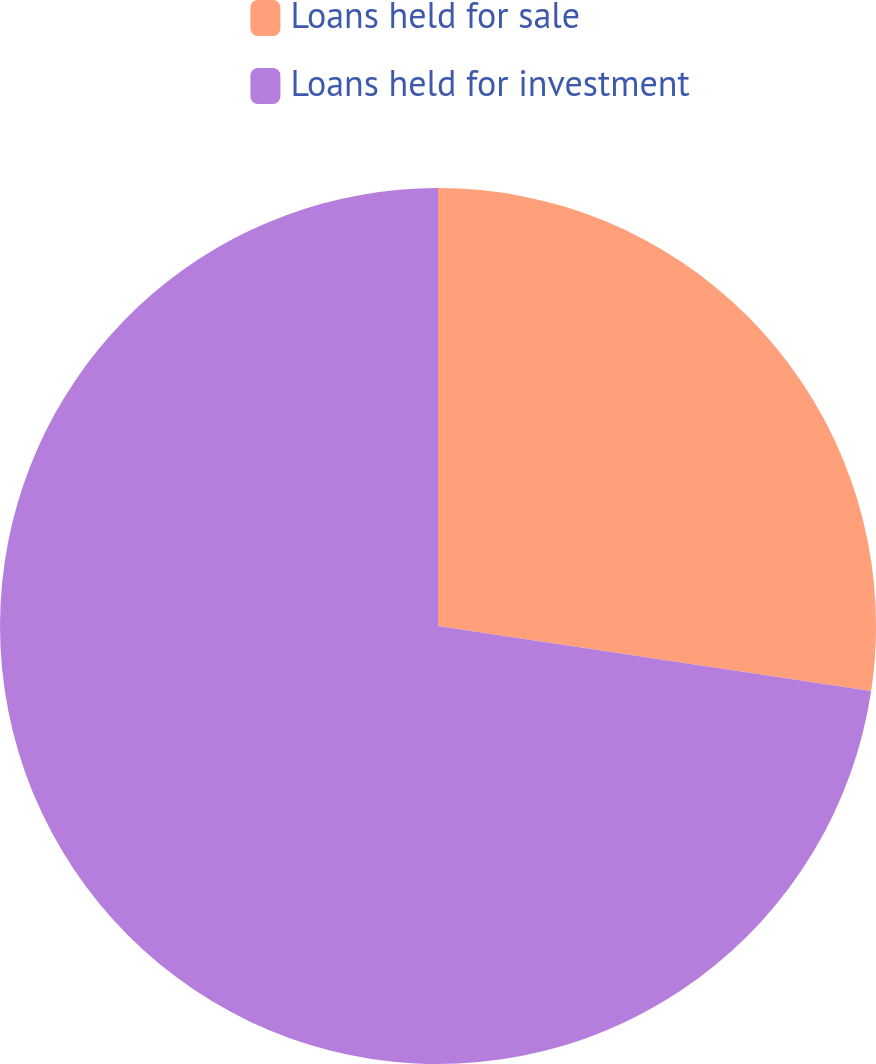<chart> <loc_0><loc_0><loc_500><loc_500><pie_chart><fcel>Loans held for sale<fcel>Loans held for investment<nl><fcel>27.37%<fcel>72.63%<nl></chart> 